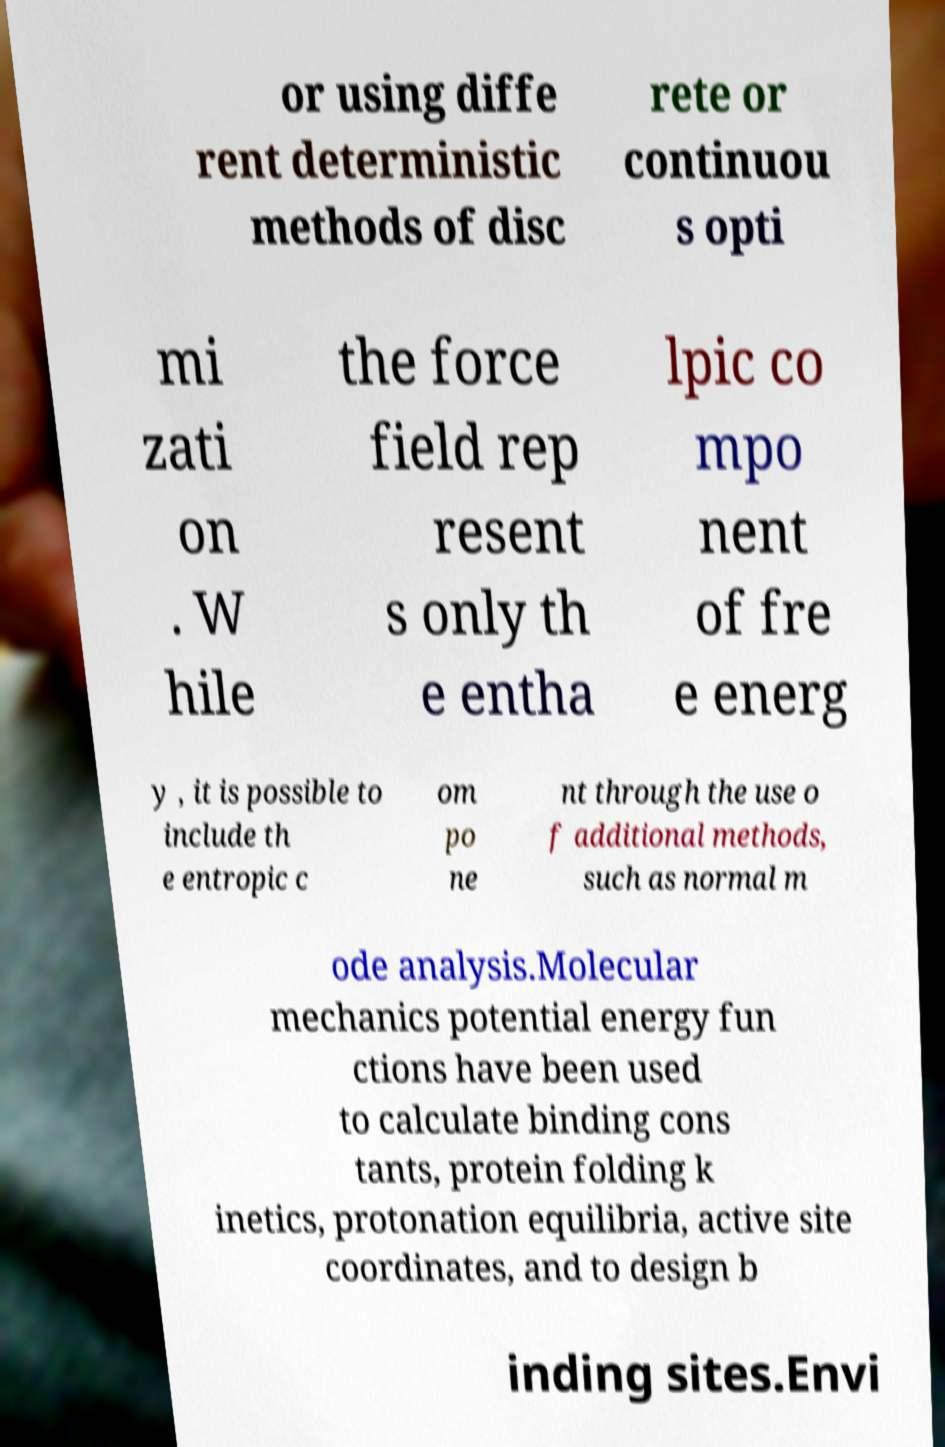Can you read and provide the text displayed in the image?This photo seems to have some interesting text. Can you extract and type it out for me? or using diffe rent deterministic methods of disc rete or continuou s opti mi zati on . W hile the force field rep resent s only th e entha lpic co mpo nent of fre e energ y , it is possible to include th e entropic c om po ne nt through the use o f additional methods, such as normal m ode analysis.Molecular mechanics potential energy fun ctions have been used to calculate binding cons tants, protein folding k inetics, protonation equilibria, active site coordinates, and to design b inding sites.Envi 